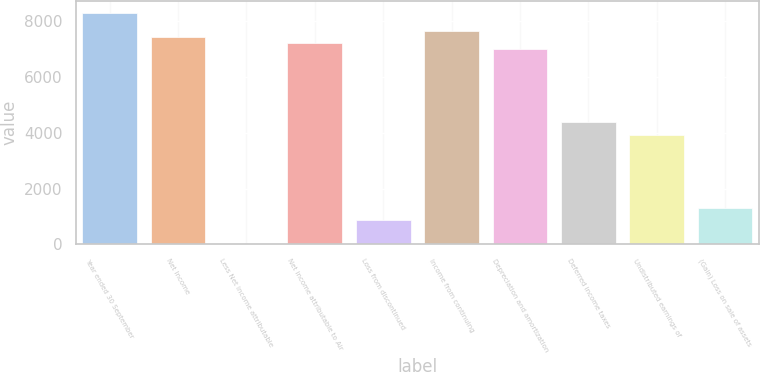Convert chart to OTSL. <chart><loc_0><loc_0><loc_500><loc_500><bar_chart><fcel>Year ended 30 September<fcel>Net Income<fcel>Less Net income attributable<fcel>Net income attributable to Air<fcel>Loss from discontinued<fcel>Income from continuing<fcel>Depreciation and amortization<fcel>Deferred income taxes<fcel>Undistributed earnings of<fcel>(Gain) Loss on sale of assets<nl><fcel>8318.46<fcel>7442.98<fcel>1.4<fcel>7224.11<fcel>876.88<fcel>7661.85<fcel>7005.24<fcel>4378.8<fcel>3941.06<fcel>1314.62<nl></chart> 